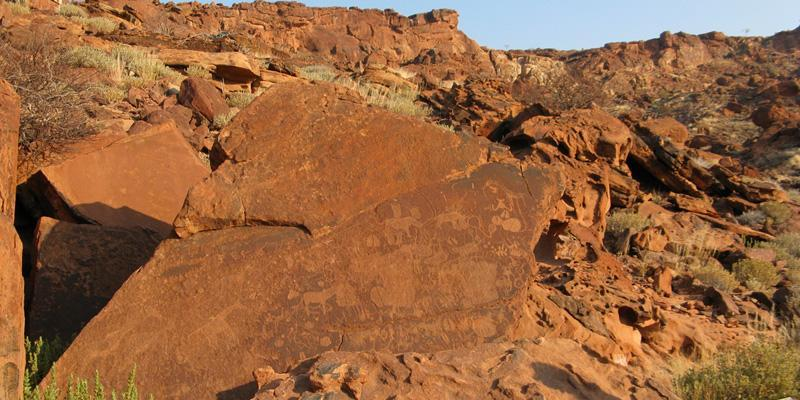Analyze the image in a comprehensive and detailed manner. The image showcases the ancient rock engravings at Twyfelfontein in Namibia, a site renowned for its archaeological and cultural significance. The photograph captures a vast, textured rock face adorned with petroglyphs that include depictions of various animals and abstract patterns, carved by ancestral tribes thousands of years ago. The rocks are bathed in a warm, reddish hue, echoing the arid landscape of Namibia. Beyond the primary focus, the background reveals a rugged hillside under a strikingly blue sky, highlighting the isolation and untouched nature of this historical site. This image not only captures the physical beauty of these engravings but also hints at the sophisticated symbolic communication used by early inhabitants of the region, offering a window into the past where art and survival intertwined under the African sun. 